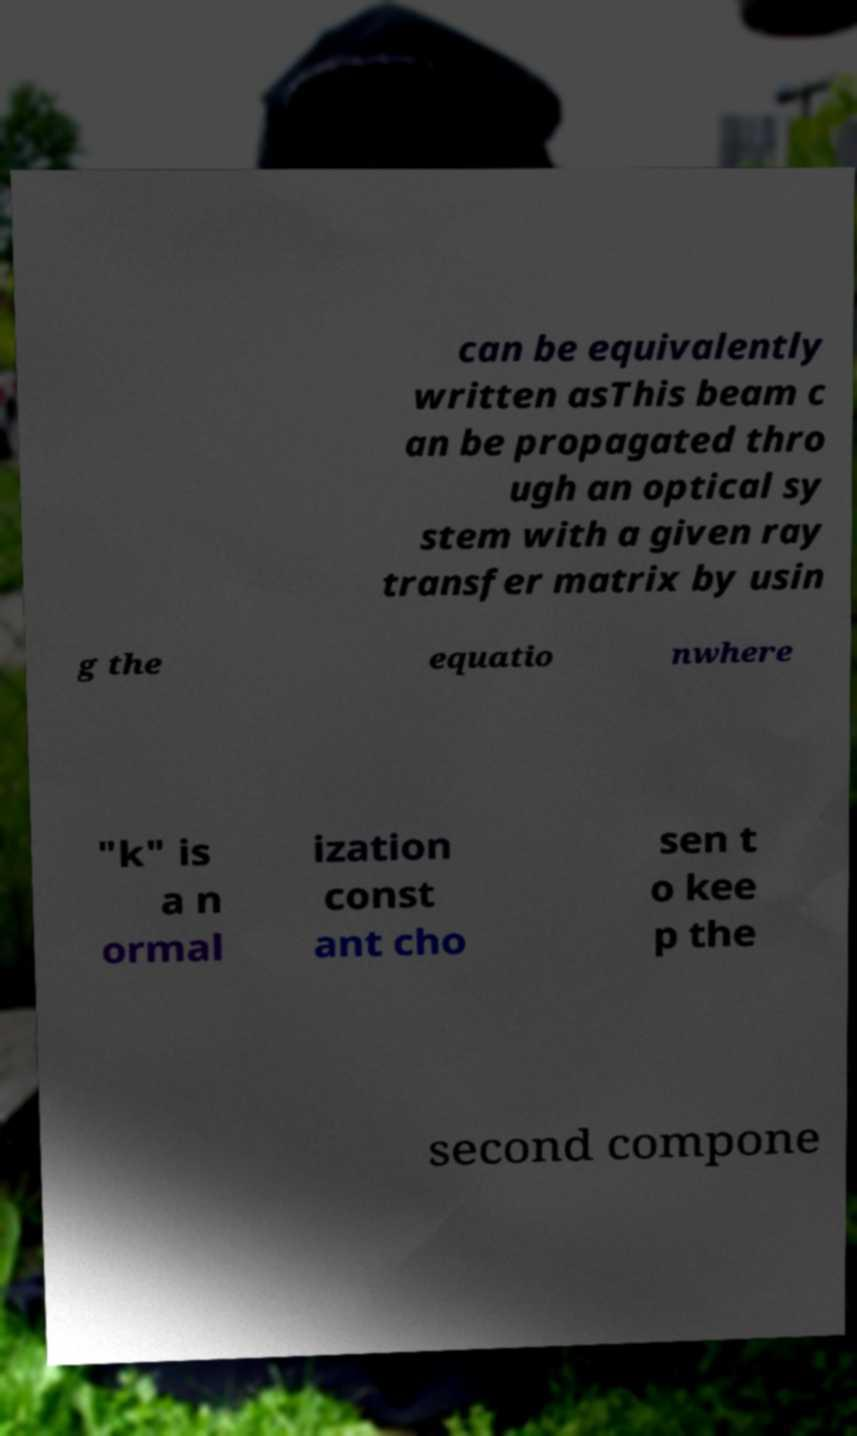Could you extract and type out the text from this image? can be equivalently written asThis beam c an be propagated thro ugh an optical sy stem with a given ray transfer matrix by usin g the equatio nwhere "k" is a n ormal ization const ant cho sen t o kee p the second compone 